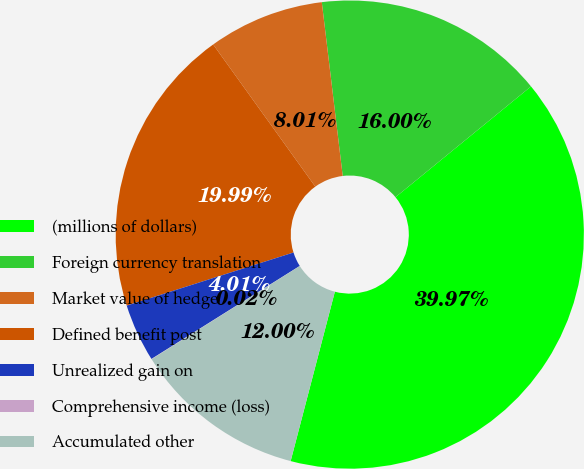Convert chart. <chart><loc_0><loc_0><loc_500><loc_500><pie_chart><fcel>(millions of dollars)<fcel>Foreign currency translation<fcel>Market value of hedge<fcel>Defined benefit post<fcel>Unrealized gain on<fcel>Comprehensive income (loss)<fcel>Accumulated other<nl><fcel>39.97%<fcel>16.0%<fcel>8.01%<fcel>19.99%<fcel>4.01%<fcel>0.02%<fcel>12.0%<nl></chart> 